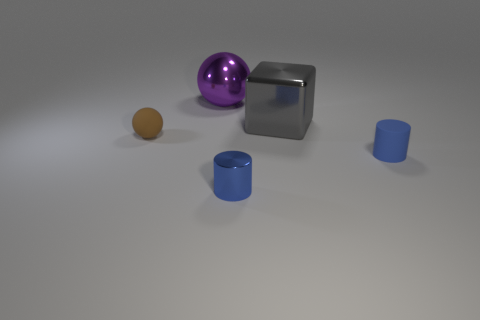Add 5 purple metal objects. How many objects exist? 10 Subtract all blocks. How many objects are left? 4 Subtract all small yellow balls. Subtract all big gray shiny things. How many objects are left? 4 Add 4 small blue shiny objects. How many small blue shiny objects are left? 5 Add 4 blue rubber cylinders. How many blue rubber cylinders exist? 5 Subtract 0 red cylinders. How many objects are left? 5 